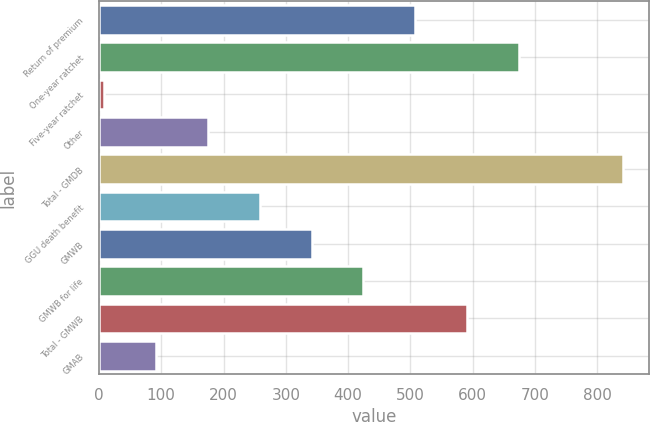Convert chart. <chart><loc_0><loc_0><loc_500><loc_500><bar_chart><fcel>Return of premium<fcel>One-year ratchet<fcel>Five-year ratchet<fcel>Other<fcel>Total - GMDB<fcel>GGU death benefit<fcel>GMWB<fcel>GMWB for life<fcel>Total - GMWB<fcel>GMAB<nl><fcel>507.8<fcel>674.4<fcel>8<fcel>174.6<fcel>841<fcel>257.9<fcel>341.2<fcel>424.5<fcel>591.1<fcel>91.3<nl></chart> 